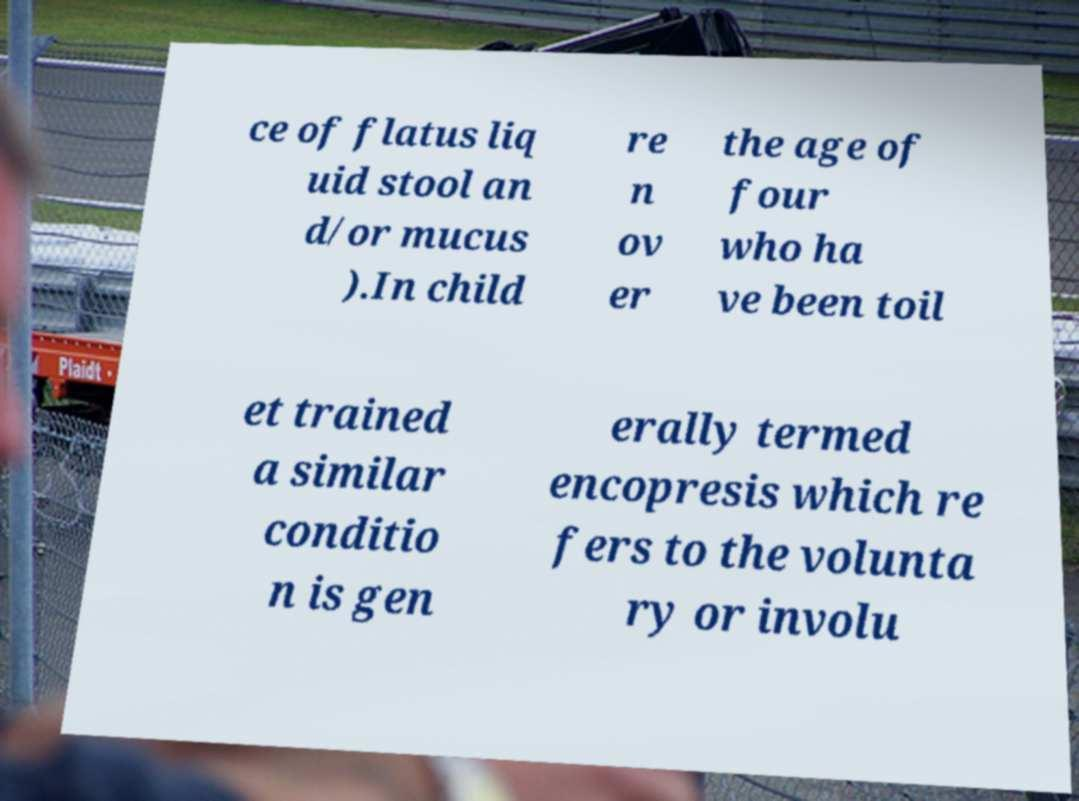Could you assist in decoding the text presented in this image and type it out clearly? ce of flatus liq uid stool an d/or mucus ).In child re n ov er the age of four who ha ve been toil et trained a similar conditio n is gen erally termed encopresis which re fers to the volunta ry or involu 